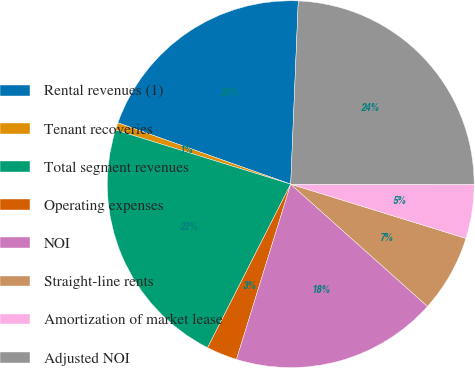<chart> <loc_0><loc_0><loc_500><loc_500><pie_chart><fcel>Rental revenues (1)<fcel>Tenant recoveries<fcel>Total segment revenues<fcel>Operating expenses<fcel>NOI<fcel>Straight-line rents<fcel>Amortization of market lease<fcel>Adjusted NOI<nl><fcel>20.23%<fcel>0.65%<fcel>22.29%<fcel>2.71%<fcel>18.17%<fcel>6.83%<fcel>4.77%<fcel>24.35%<nl></chart> 